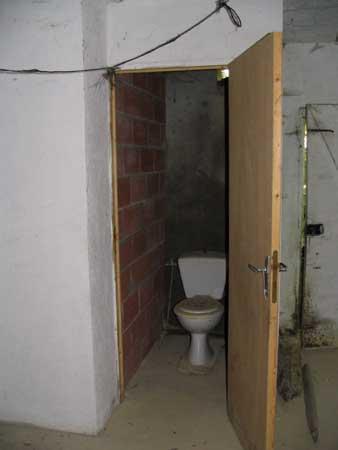How many sinks?
Give a very brief answer. 0. How many buses are on the street?
Give a very brief answer. 0. 